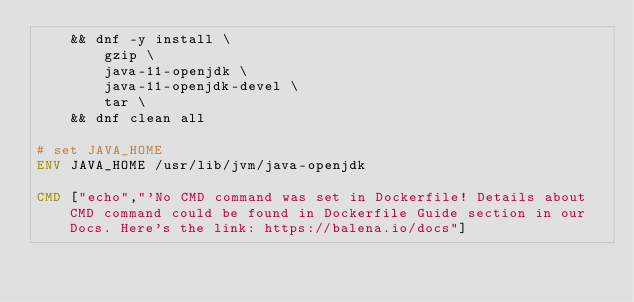<code> <loc_0><loc_0><loc_500><loc_500><_Dockerfile_>	&& dnf -y install \
		gzip \
		java-11-openjdk \
		java-11-openjdk-devel \
		tar \
	&& dnf clean all

# set JAVA_HOME
ENV JAVA_HOME /usr/lib/jvm/java-openjdk

CMD ["echo","'No CMD command was set in Dockerfile! Details about CMD command could be found in Dockerfile Guide section in our Docs. Here's the link: https://balena.io/docs"]
</code> 